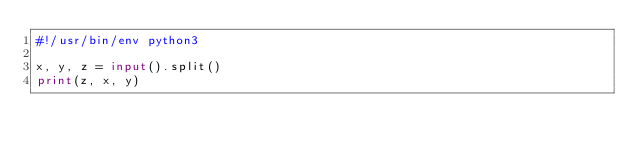Convert code to text. <code><loc_0><loc_0><loc_500><loc_500><_Python_>#!/usr/bin/env python3

x, y, z = input().split()
print(z, x, y)</code> 